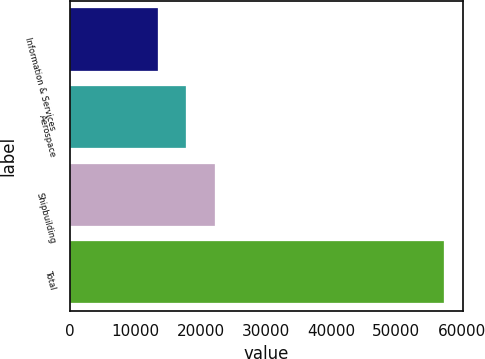<chart> <loc_0><loc_0><loc_500><loc_500><bar_chart><fcel>Information & Services<fcel>Aerospace<fcel>Shipbuilding<fcel>Total<nl><fcel>13437<fcel>17826.4<fcel>22215.8<fcel>57331<nl></chart> 